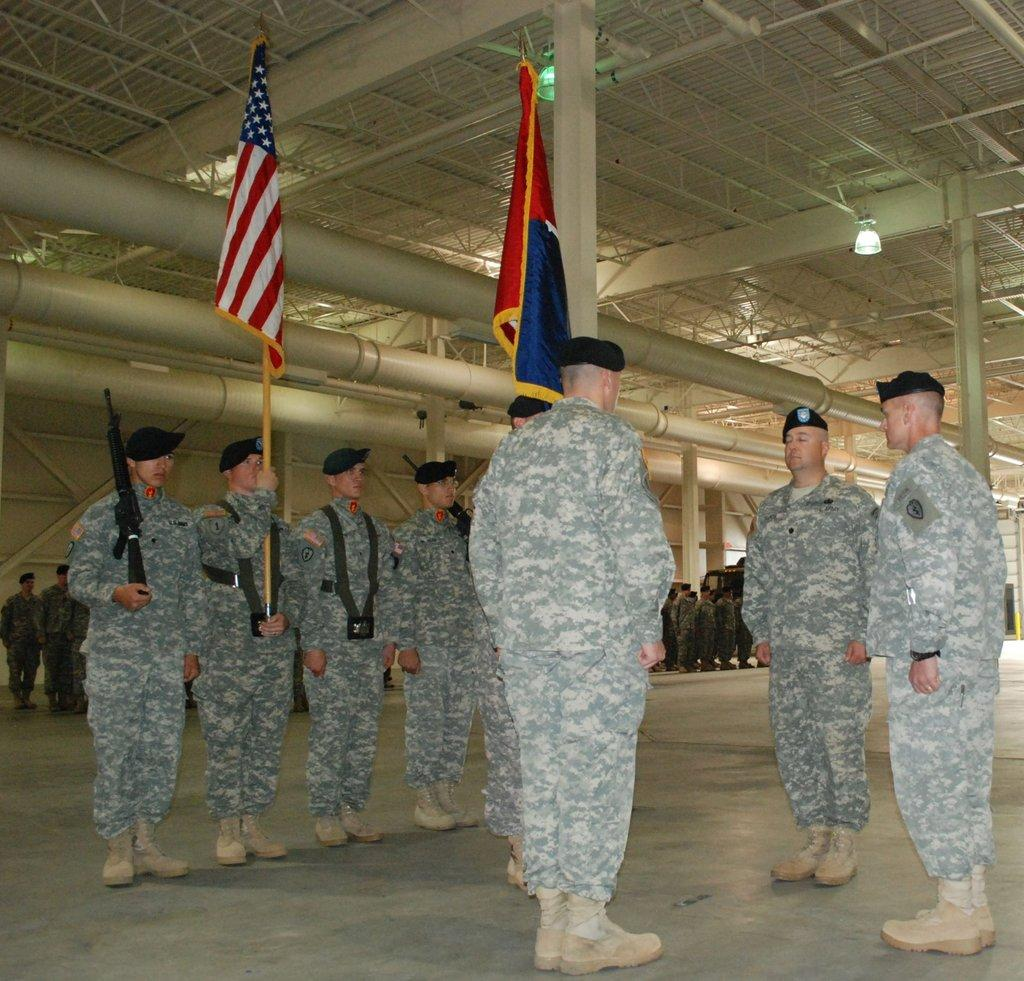What are the people in the image wearing? The people in the image are wearing the same uniform. What are two of the people holding? Two of the people are holding flags. Can you describe the background of the image? There are other people visible in the background. What is on the roof in the image? There are lights on the roof. What type of soap is being used by the people in the image? There is no soap present in the image, as the people are holding flags and wearing uniforms. 